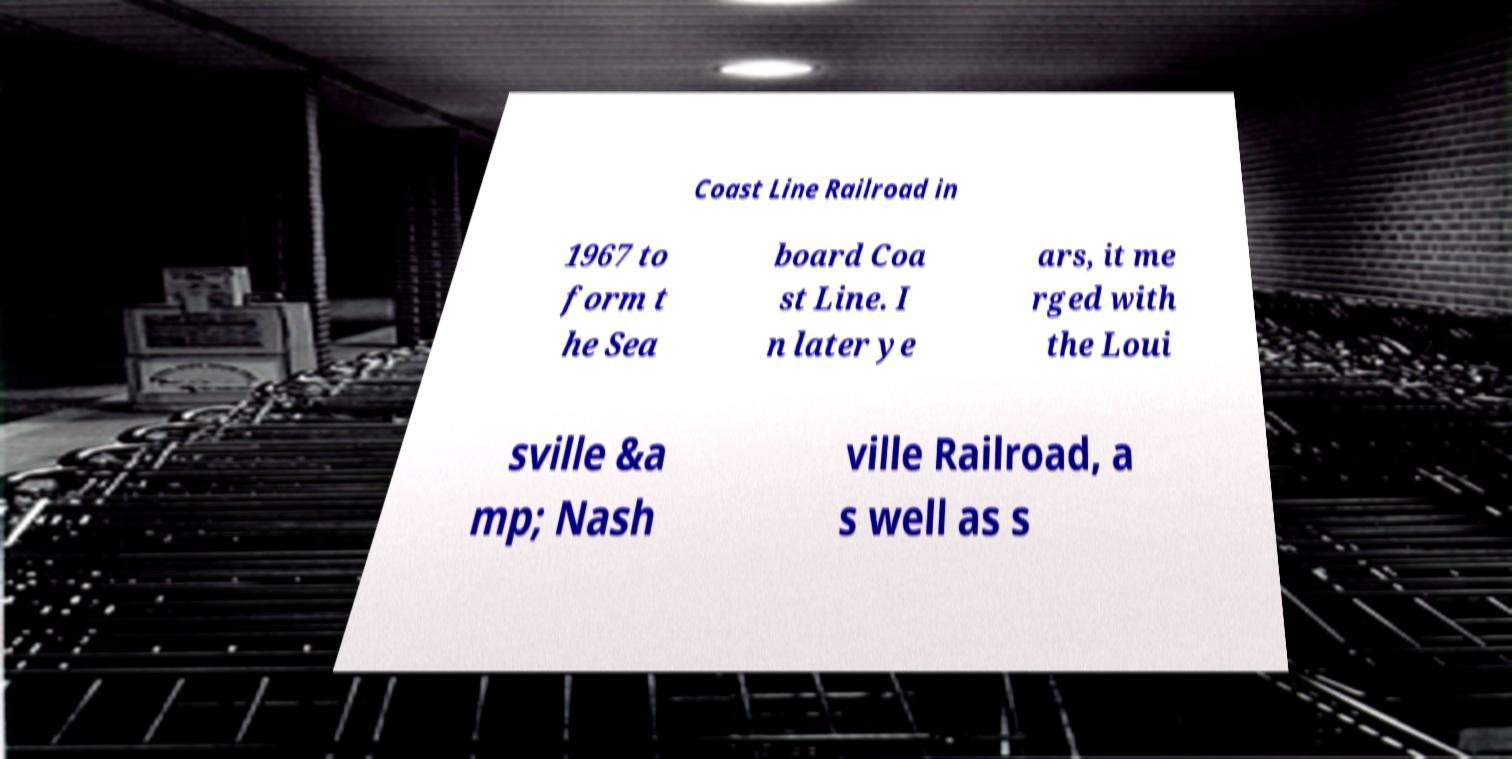What messages or text are displayed in this image? I need them in a readable, typed format. Coast Line Railroad in 1967 to form t he Sea board Coa st Line. I n later ye ars, it me rged with the Loui sville &a mp; Nash ville Railroad, a s well as s 